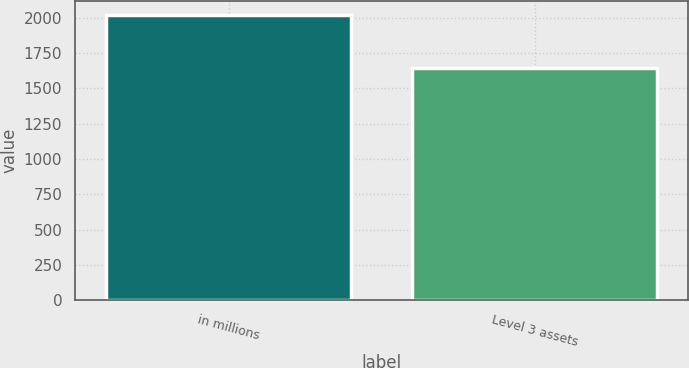<chart> <loc_0><loc_0><loc_500><loc_500><bar_chart><fcel>in millions<fcel>Level 3 assets<nl><fcel>2016<fcel>1645<nl></chart> 